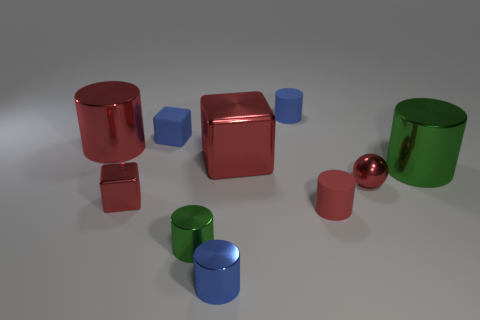Subtract all red cylinders. How many were subtracted if there are1red cylinders left? 1 Subtract all red cylinders. How many cylinders are left? 4 Subtract all red cylinders. How many cylinders are left? 4 Subtract all gray cylinders. Subtract all yellow spheres. How many cylinders are left? 6 Subtract all balls. How many objects are left? 9 Add 3 blue rubber objects. How many blue rubber objects exist? 5 Subtract 1 red cylinders. How many objects are left? 9 Subtract all small metal cylinders. Subtract all small blue shiny things. How many objects are left? 7 Add 7 large shiny objects. How many large shiny objects are left? 10 